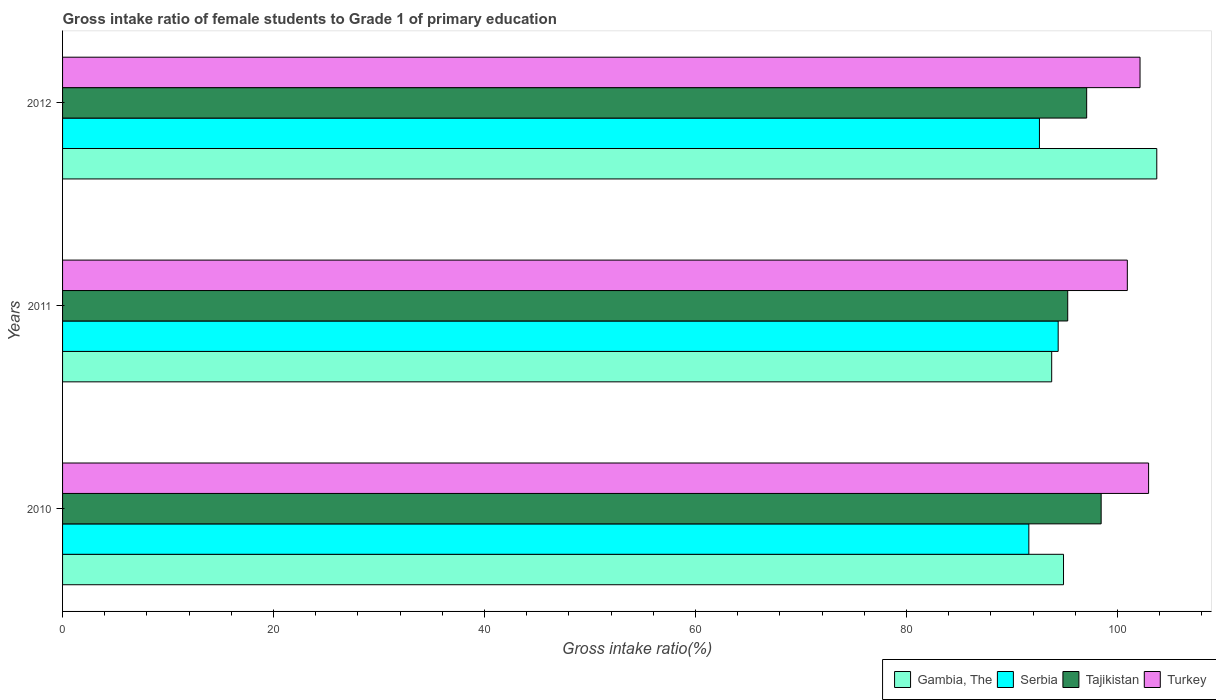How many groups of bars are there?
Offer a very short reply. 3. Are the number of bars per tick equal to the number of legend labels?
Give a very brief answer. Yes. How many bars are there on the 3rd tick from the top?
Offer a very short reply. 4. How many bars are there on the 2nd tick from the bottom?
Provide a short and direct response. 4. What is the label of the 1st group of bars from the top?
Your answer should be compact. 2012. In how many cases, is the number of bars for a given year not equal to the number of legend labels?
Provide a short and direct response. 0. What is the gross intake ratio in Serbia in 2012?
Your response must be concise. 92.6. Across all years, what is the maximum gross intake ratio in Turkey?
Keep it short and to the point. 102.95. Across all years, what is the minimum gross intake ratio in Tajikistan?
Provide a short and direct response. 95.28. In which year was the gross intake ratio in Serbia maximum?
Ensure brevity in your answer.  2011. In which year was the gross intake ratio in Serbia minimum?
Make the answer very short. 2010. What is the total gross intake ratio in Tajikistan in the graph?
Your response must be concise. 290.81. What is the difference between the gross intake ratio in Tajikistan in 2011 and that in 2012?
Make the answer very short. -1.8. What is the difference between the gross intake ratio in Tajikistan in 2011 and the gross intake ratio in Gambia, The in 2012?
Provide a short and direct response. -8.44. What is the average gross intake ratio in Gambia, The per year?
Offer a terse response. 97.46. In the year 2012, what is the difference between the gross intake ratio in Turkey and gross intake ratio in Gambia, The?
Make the answer very short. -1.59. In how many years, is the gross intake ratio in Serbia greater than 12 %?
Provide a succinct answer. 3. What is the ratio of the gross intake ratio in Tajikistan in 2010 to that in 2011?
Keep it short and to the point. 1.03. Is the difference between the gross intake ratio in Turkey in 2011 and 2012 greater than the difference between the gross intake ratio in Gambia, The in 2011 and 2012?
Provide a succinct answer. Yes. What is the difference between the highest and the second highest gross intake ratio in Gambia, The?
Provide a short and direct response. 8.84. What is the difference between the highest and the lowest gross intake ratio in Turkey?
Keep it short and to the point. 2.02. In how many years, is the gross intake ratio in Turkey greater than the average gross intake ratio in Turkey taken over all years?
Ensure brevity in your answer.  2. Is the sum of the gross intake ratio in Turkey in 2011 and 2012 greater than the maximum gross intake ratio in Tajikistan across all years?
Make the answer very short. Yes. Is it the case that in every year, the sum of the gross intake ratio in Tajikistan and gross intake ratio in Turkey is greater than the gross intake ratio in Gambia, The?
Your answer should be compact. Yes. How many bars are there?
Provide a succinct answer. 12. Are all the bars in the graph horizontal?
Offer a very short reply. Yes. Does the graph contain grids?
Offer a very short reply. No. What is the title of the graph?
Offer a terse response. Gross intake ratio of female students to Grade 1 of primary education. Does "Mali" appear as one of the legend labels in the graph?
Offer a terse response. No. What is the label or title of the X-axis?
Offer a terse response. Gross intake ratio(%). What is the label or title of the Y-axis?
Keep it short and to the point. Years. What is the Gross intake ratio(%) in Gambia, The in 2010?
Your answer should be very brief. 94.88. What is the Gross intake ratio(%) of Serbia in 2010?
Offer a very short reply. 91.6. What is the Gross intake ratio(%) in Tajikistan in 2010?
Provide a short and direct response. 98.45. What is the Gross intake ratio(%) of Turkey in 2010?
Your answer should be very brief. 102.95. What is the Gross intake ratio(%) in Gambia, The in 2011?
Ensure brevity in your answer.  93.76. What is the Gross intake ratio(%) of Serbia in 2011?
Offer a very short reply. 94.38. What is the Gross intake ratio(%) in Tajikistan in 2011?
Keep it short and to the point. 95.28. What is the Gross intake ratio(%) in Turkey in 2011?
Provide a short and direct response. 100.93. What is the Gross intake ratio(%) in Gambia, The in 2012?
Give a very brief answer. 103.73. What is the Gross intake ratio(%) of Serbia in 2012?
Provide a succinct answer. 92.6. What is the Gross intake ratio(%) of Tajikistan in 2012?
Provide a succinct answer. 97.08. What is the Gross intake ratio(%) of Turkey in 2012?
Ensure brevity in your answer.  102.14. Across all years, what is the maximum Gross intake ratio(%) in Gambia, The?
Your answer should be compact. 103.73. Across all years, what is the maximum Gross intake ratio(%) of Serbia?
Make the answer very short. 94.38. Across all years, what is the maximum Gross intake ratio(%) in Tajikistan?
Ensure brevity in your answer.  98.45. Across all years, what is the maximum Gross intake ratio(%) in Turkey?
Give a very brief answer. 102.95. Across all years, what is the minimum Gross intake ratio(%) of Gambia, The?
Give a very brief answer. 93.76. Across all years, what is the minimum Gross intake ratio(%) in Serbia?
Provide a succinct answer. 91.6. Across all years, what is the minimum Gross intake ratio(%) of Tajikistan?
Your answer should be very brief. 95.28. Across all years, what is the minimum Gross intake ratio(%) of Turkey?
Keep it short and to the point. 100.93. What is the total Gross intake ratio(%) of Gambia, The in the graph?
Your response must be concise. 292.37. What is the total Gross intake ratio(%) in Serbia in the graph?
Your answer should be compact. 278.58. What is the total Gross intake ratio(%) of Tajikistan in the graph?
Your response must be concise. 290.81. What is the total Gross intake ratio(%) of Turkey in the graph?
Provide a succinct answer. 306.02. What is the difference between the Gross intake ratio(%) in Gambia, The in 2010 and that in 2011?
Ensure brevity in your answer.  1.12. What is the difference between the Gross intake ratio(%) of Serbia in 2010 and that in 2011?
Give a very brief answer. -2.78. What is the difference between the Gross intake ratio(%) in Tajikistan in 2010 and that in 2011?
Ensure brevity in your answer.  3.17. What is the difference between the Gross intake ratio(%) of Turkey in 2010 and that in 2011?
Provide a succinct answer. 2.02. What is the difference between the Gross intake ratio(%) in Gambia, The in 2010 and that in 2012?
Your response must be concise. -8.84. What is the difference between the Gross intake ratio(%) of Serbia in 2010 and that in 2012?
Offer a terse response. -1. What is the difference between the Gross intake ratio(%) in Tajikistan in 2010 and that in 2012?
Keep it short and to the point. 1.37. What is the difference between the Gross intake ratio(%) of Turkey in 2010 and that in 2012?
Provide a succinct answer. 0.81. What is the difference between the Gross intake ratio(%) of Gambia, The in 2011 and that in 2012?
Provide a succinct answer. -9.96. What is the difference between the Gross intake ratio(%) in Serbia in 2011 and that in 2012?
Make the answer very short. 1.78. What is the difference between the Gross intake ratio(%) of Tajikistan in 2011 and that in 2012?
Ensure brevity in your answer.  -1.8. What is the difference between the Gross intake ratio(%) of Turkey in 2011 and that in 2012?
Give a very brief answer. -1.2. What is the difference between the Gross intake ratio(%) in Gambia, The in 2010 and the Gross intake ratio(%) in Serbia in 2011?
Your response must be concise. 0.51. What is the difference between the Gross intake ratio(%) of Gambia, The in 2010 and the Gross intake ratio(%) of Tajikistan in 2011?
Give a very brief answer. -0.4. What is the difference between the Gross intake ratio(%) of Gambia, The in 2010 and the Gross intake ratio(%) of Turkey in 2011?
Ensure brevity in your answer.  -6.05. What is the difference between the Gross intake ratio(%) in Serbia in 2010 and the Gross intake ratio(%) in Tajikistan in 2011?
Provide a succinct answer. -3.68. What is the difference between the Gross intake ratio(%) in Serbia in 2010 and the Gross intake ratio(%) in Turkey in 2011?
Keep it short and to the point. -9.34. What is the difference between the Gross intake ratio(%) of Tajikistan in 2010 and the Gross intake ratio(%) of Turkey in 2011?
Provide a succinct answer. -2.48. What is the difference between the Gross intake ratio(%) in Gambia, The in 2010 and the Gross intake ratio(%) in Serbia in 2012?
Offer a terse response. 2.28. What is the difference between the Gross intake ratio(%) of Gambia, The in 2010 and the Gross intake ratio(%) of Tajikistan in 2012?
Your response must be concise. -2.2. What is the difference between the Gross intake ratio(%) in Gambia, The in 2010 and the Gross intake ratio(%) in Turkey in 2012?
Provide a short and direct response. -7.25. What is the difference between the Gross intake ratio(%) of Serbia in 2010 and the Gross intake ratio(%) of Tajikistan in 2012?
Your response must be concise. -5.48. What is the difference between the Gross intake ratio(%) in Serbia in 2010 and the Gross intake ratio(%) in Turkey in 2012?
Offer a terse response. -10.54. What is the difference between the Gross intake ratio(%) in Tajikistan in 2010 and the Gross intake ratio(%) in Turkey in 2012?
Provide a short and direct response. -3.69. What is the difference between the Gross intake ratio(%) of Gambia, The in 2011 and the Gross intake ratio(%) of Serbia in 2012?
Make the answer very short. 1.16. What is the difference between the Gross intake ratio(%) in Gambia, The in 2011 and the Gross intake ratio(%) in Tajikistan in 2012?
Offer a very short reply. -3.32. What is the difference between the Gross intake ratio(%) in Gambia, The in 2011 and the Gross intake ratio(%) in Turkey in 2012?
Your response must be concise. -8.37. What is the difference between the Gross intake ratio(%) of Serbia in 2011 and the Gross intake ratio(%) of Tajikistan in 2012?
Make the answer very short. -2.7. What is the difference between the Gross intake ratio(%) in Serbia in 2011 and the Gross intake ratio(%) in Turkey in 2012?
Provide a short and direct response. -7.76. What is the difference between the Gross intake ratio(%) in Tajikistan in 2011 and the Gross intake ratio(%) in Turkey in 2012?
Offer a terse response. -6.85. What is the average Gross intake ratio(%) of Gambia, The per year?
Provide a short and direct response. 97.46. What is the average Gross intake ratio(%) of Serbia per year?
Ensure brevity in your answer.  92.86. What is the average Gross intake ratio(%) of Tajikistan per year?
Keep it short and to the point. 96.94. What is the average Gross intake ratio(%) in Turkey per year?
Ensure brevity in your answer.  102.01. In the year 2010, what is the difference between the Gross intake ratio(%) of Gambia, The and Gross intake ratio(%) of Serbia?
Give a very brief answer. 3.29. In the year 2010, what is the difference between the Gross intake ratio(%) of Gambia, The and Gross intake ratio(%) of Tajikistan?
Your response must be concise. -3.57. In the year 2010, what is the difference between the Gross intake ratio(%) in Gambia, The and Gross intake ratio(%) in Turkey?
Offer a terse response. -8.07. In the year 2010, what is the difference between the Gross intake ratio(%) of Serbia and Gross intake ratio(%) of Tajikistan?
Provide a short and direct response. -6.85. In the year 2010, what is the difference between the Gross intake ratio(%) in Serbia and Gross intake ratio(%) in Turkey?
Provide a succinct answer. -11.35. In the year 2010, what is the difference between the Gross intake ratio(%) of Tajikistan and Gross intake ratio(%) of Turkey?
Ensure brevity in your answer.  -4.5. In the year 2011, what is the difference between the Gross intake ratio(%) of Gambia, The and Gross intake ratio(%) of Serbia?
Keep it short and to the point. -0.61. In the year 2011, what is the difference between the Gross intake ratio(%) of Gambia, The and Gross intake ratio(%) of Tajikistan?
Give a very brief answer. -1.52. In the year 2011, what is the difference between the Gross intake ratio(%) in Gambia, The and Gross intake ratio(%) in Turkey?
Ensure brevity in your answer.  -7.17. In the year 2011, what is the difference between the Gross intake ratio(%) in Serbia and Gross intake ratio(%) in Tajikistan?
Ensure brevity in your answer.  -0.91. In the year 2011, what is the difference between the Gross intake ratio(%) of Serbia and Gross intake ratio(%) of Turkey?
Give a very brief answer. -6.56. In the year 2011, what is the difference between the Gross intake ratio(%) of Tajikistan and Gross intake ratio(%) of Turkey?
Provide a short and direct response. -5.65. In the year 2012, what is the difference between the Gross intake ratio(%) of Gambia, The and Gross intake ratio(%) of Serbia?
Offer a very short reply. 11.12. In the year 2012, what is the difference between the Gross intake ratio(%) of Gambia, The and Gross intake ratio(%) of Tajikistan?
Provide a short and direct response. 6.65. In the year 2012, what is the difference between the Gross intake ratio(%) of Gambia, The and Gross intake ratio(%) of Turkey?
Offer a terse response. 1.59. In the year 2012, what is the difference between the Gross intake ratio(%) in Serbia and Gross intake ratio(%) in Tajikistan?
Your answer should be compact. -4.48. In the year 2012, what is the difference between the Gross intake ratio(%) of Serbia and Gross intake ratio(%) of Turkey?
Provide a short and direct response. -9.54. In the year 2012, what is the difference between the Gross intake ratio(%) in Tajikistan and Gross intake ratio(%) in Turkey?
Provide a succinct answer. -5.06. What is the ratio of the Gross intake ratio(%) in Serbia in 2010 to that in 2011?
Offer a very short reply. 0.97. What is the ratio of the Gross intake ratio(%) in Tajikistan in 2010 to that in 2011?
Offer a terse response. 1.03. What is the ratio of the Gross intake ratio(%) of Turkey in 2010 to that in 2011?
Ensure brevity in your answer.  1.02. What is the ratio of the Gross intake ratio(%) of Gambia, The in 2010 to that in 2012?
Make the answer very short. 0.91. What is the ratio of the Gross intake ratio(%) in Tajikistan in 2010 to that in 2012?
Your answer should be very brief. 1.01. What is the ratio of the Gross intake ratio(%) in Gambia, The in 2011 to that in 2012?
Ensure brevity in your answer.  0.9. What is the ratio of the Gross intake ratio(%) in Serbia in 2011 to that in 2012?
Keep it short and to the point. 1.02. What is the ratio of the Gross intake ratio(%) in Tajikistan in 2011 to that in 2012?
Your response must be concise. 0.98. What is the difference between the highest and the second highest Gross intake ratio(%) in Gambia, The?
Provide a succinct answer. 8.84. What is the difference between the highest and the second highest Gross intake ratio(%) of Serbia?
Your answer should be compact. 1.78. What is the difference between the highest and the second highest Gross intake ratio(%) of Tajikistan?
Ensure brevity in your answer.  1.37. What is the difference between the highest and the second highest Gross intake ratio(%) of Turkey?
Give a very brief answer. 0.81. What is the difference between the highest and the lowest Gross intake ratio(%) of Gambia, The?
Keep it short and to the point. 9.96. What is the difference between the highest and the lowest Gross intake ratio(%) of Serbia?
Ensure brevity in your answer.  2.78. What is the difference between the highest and the lowest Gross intake ratio(%) of Tajikistan?
Give a very brief answer. 3.17. What is the difference between the highest and the lowest Gross intake ratio(%) of Turkey?
Your response must be concise. 2.02. 